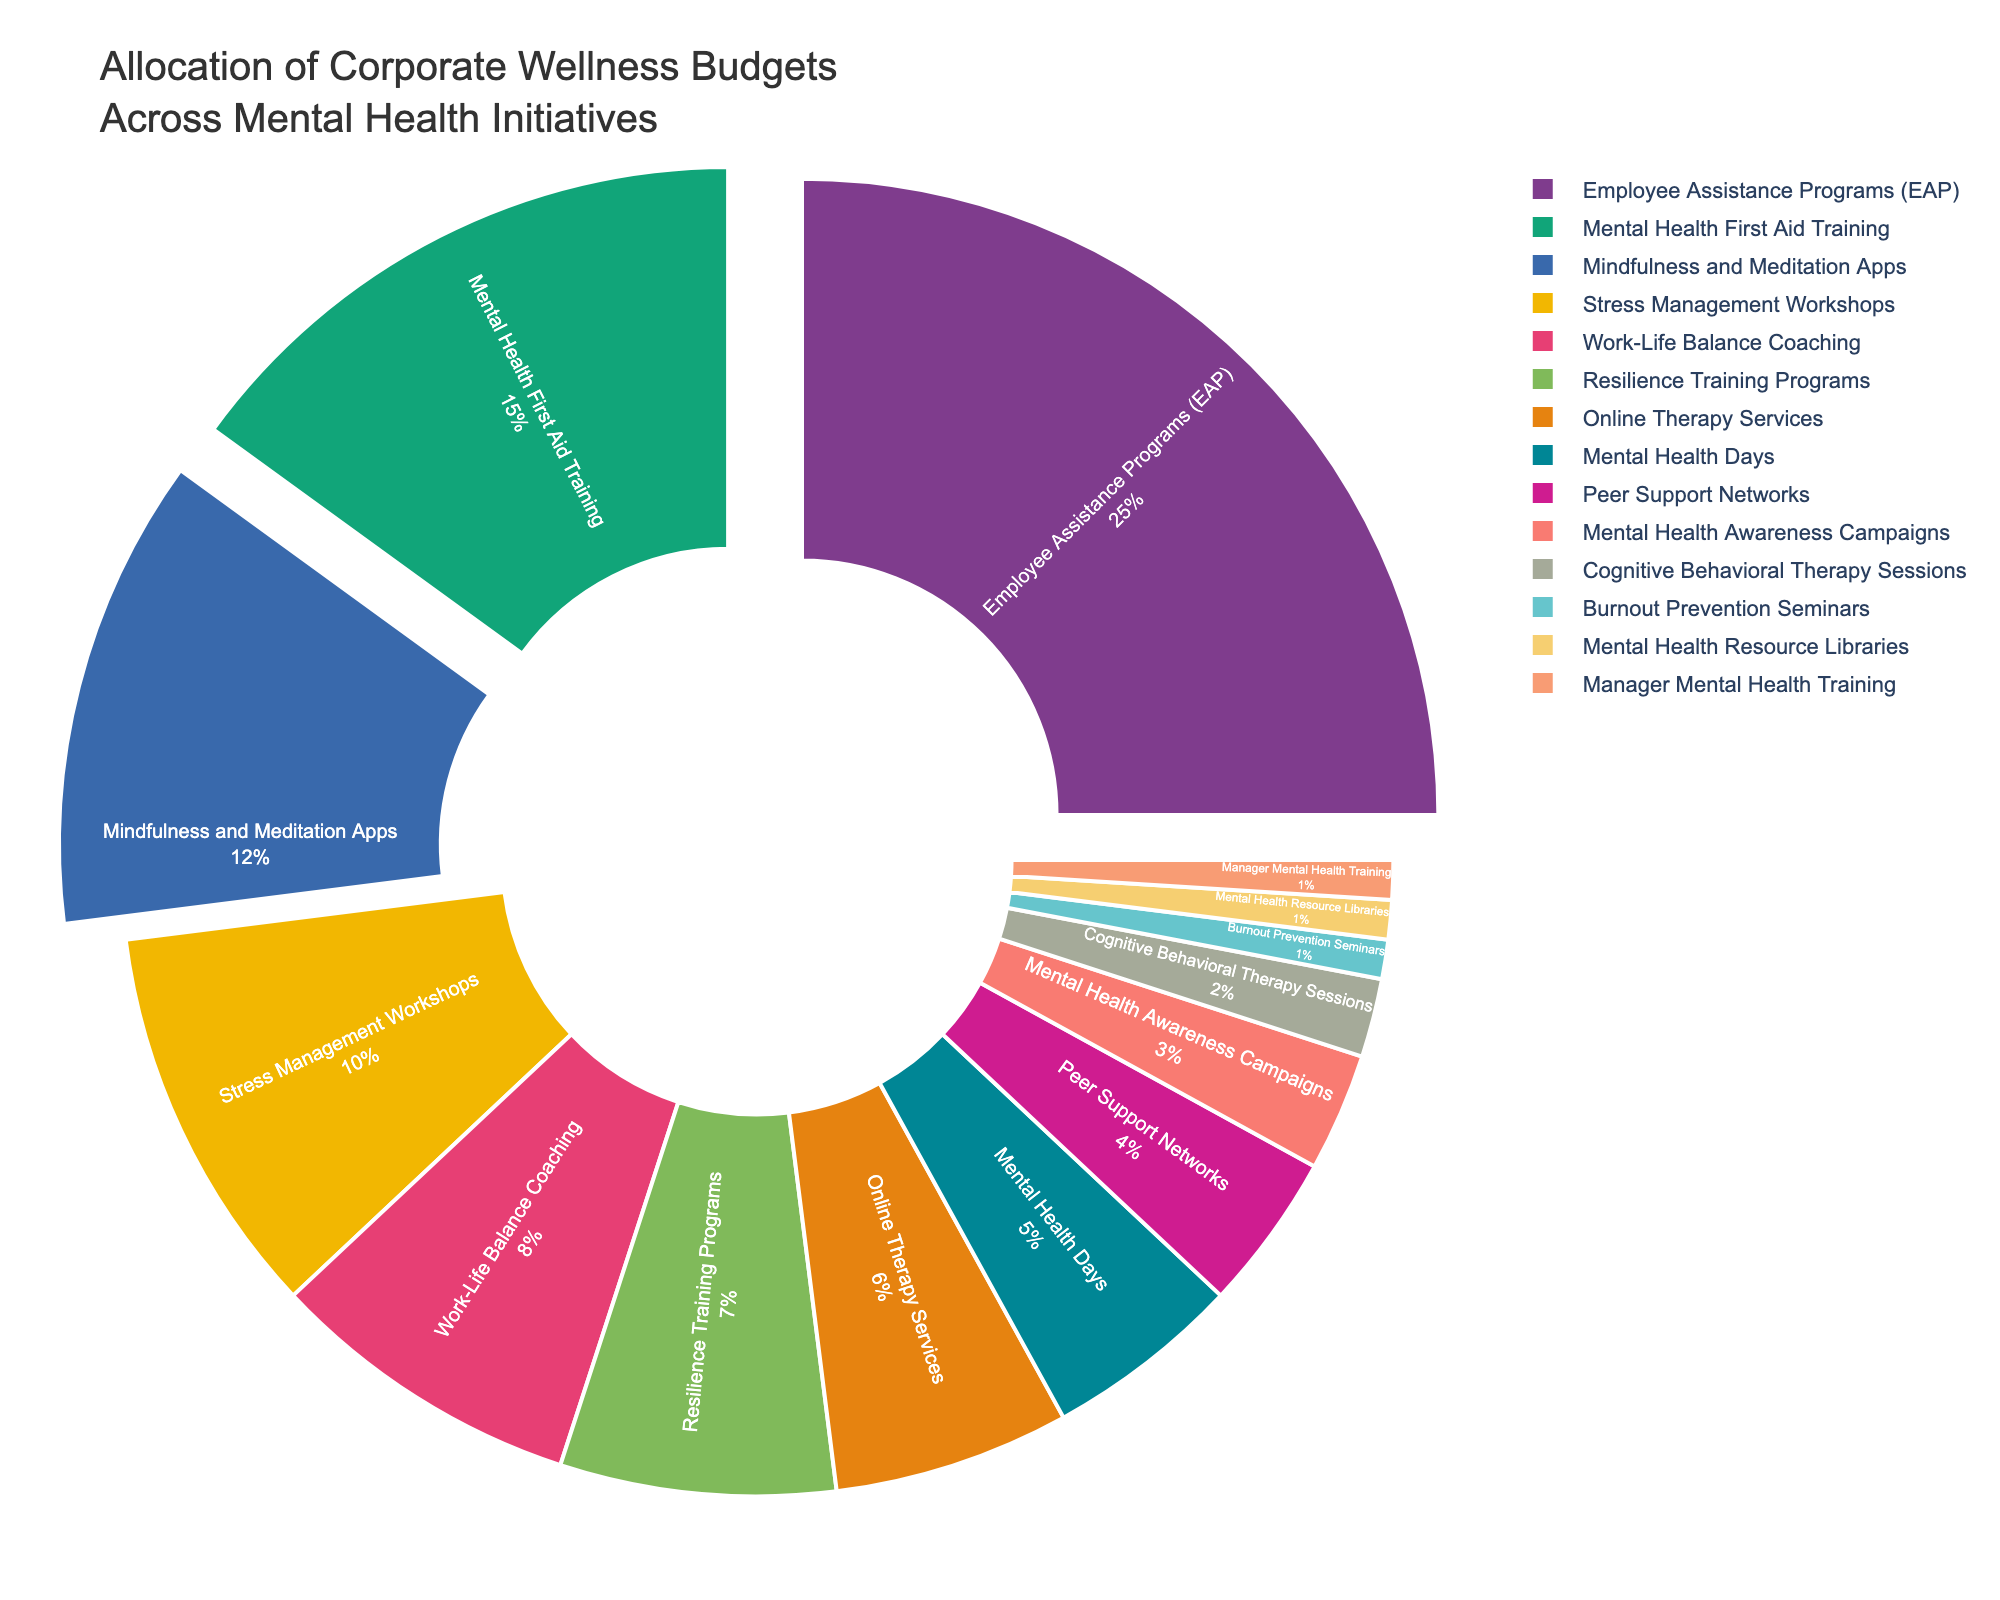what is the initiative with the highest budget allocation? The largest section of the pie chart is for Employee Assistance Programs (EAP), indicating it has the highest percentage allocation.
Answer: Employee Assistance Programs (EAP) which initiatives together make up 30%? Mental Health First Aid Training and Mindfulness and Meditation Apps together make up 15% + 12% = 27%. To reach 30%, we need one more initiative. Adding Stress Management Workshops gives us 10%, bringing the total to 27% + 10% = 37%. Thus, we need to consider the slightly lower allocation initiatives.
Answer: Mental Health First Aid Training and Mindfulness and Meditation Apps how much more is allocated to Employee Assistance Programs (EAP) compared to Online Therapy Services? The chart shows 25% allocated to Employee Assistance Programs (EAP) and 6% for Online Therapy Services. The difference is 25% - 6%.
Answer: 19% which two initiatives have an equal budget allocation? Several sections are of equal size. The three initiatives that each get 1% of the budget are Burnout Prevention Seminars, Mental Health Resource Libraries, and Manager Mental Health Training.
Answer: Burnout Prevention Seminars, Mental Health Resource Libraries, and Manager Mental Health Training what is the third-highest allocated initiative? The third largest slice of the pie chart is labeled Mindfulness and Meditation Apps, with a 12% allocation.
Answer: Mindfulness and Meditation Apps what percentage of the budget is allocated to the initiatives with the lowest allocation? The three initiatives with the lowest allocation are Burnout Prevention Seminars, Mental Health Resource Libraries, and Manager Mental Health Training, each receiving 1%. So the total allocation for these initiatives is 1% + 1% + 1%.
Answer: 3% which initiatives have a greater budget than Work-Life Balance Coaching? Work-Life Balance Coaching has an 8% allocation. The initiatives with greater allocations are Employee Assistance Programs (25%), Mental Health First Aid Training (15%), Mindfulness and Meditation Apps (12%), and Stress Management Workshops (10%).
Answer: Employee Assistance Programs, Mental Health First Aid Training, Mindfulness and Meditation Apps, Stress Management Workshops what is the average allocation percentage of the top 4 initiatives? The top 4 initiatives by allocation are Employee Assistance Programs (25%), Mental Health First Aid Training (15%), Mindfulness and Meditation Apps (12%), and Stress Management Workshops (10%). The sum is 25% + 15% + 12% + 10% = 62%. To get the average, divide by 4: 62% / 4.
Answer: 15.5% what color represents Cognitive Behavioral Therapy Sessions? In the pie chart, each slice is represented by a distinct color. The variation of colors is organized, and based on the legend, Cognitive Behavioral Therapy Sessions is typically a smaller section towards the bottom with a distinct color (noting from the description).
Answer: Based on the color palette used, identify the specific color for Cognitive Behavioral Therapy Sessions which initiatives have a combined budget of less than 10%? Initiatives with less than 10% individually are Online Therapy Services (6%), Mental Health Days (5%), Peer Support Networks (4%), Mental Health Awareness Campaigns (3%), Cognitive Behavioral Therapy Sessions (2%), Burnout Prevention Seminars (1%), Mental Health Resource Libraries (1%), and Manager Mental Health Training (1%). Combined these make 6% + 5% + 4% + 3% + 2% + 1% + 1% + 1%.
Answer: Online Therapy Services, Mental Health Days, Peer Support Networks, Mental Health Awareness Campaigns, Cognitive Behavioral Therapy Sessions, Burnout Prevention Seminars, Mental Health Resource Libraries, Manager Mental Health Training 